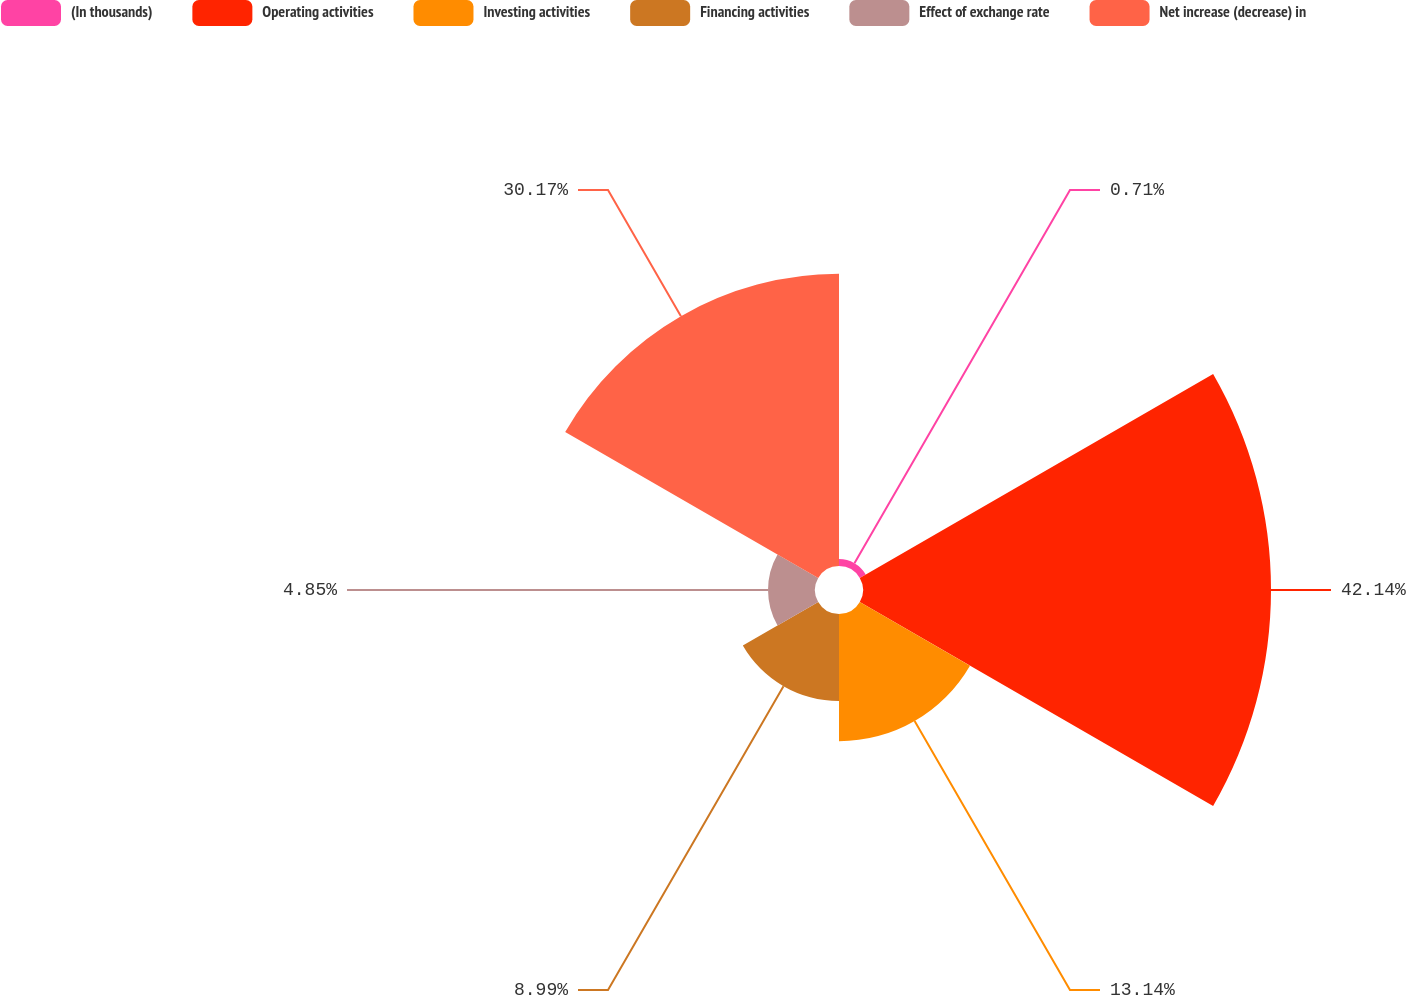<chart> <loc_0><loc_0><loc_500><loc_500><pie_chart><fcel>(In thousands)<fcel>Operating activities<fcel>Investing activities<fcel>Financing activities<fcel>Effect of exchange rate<fcel>Net increase (decrease) in<nl><fcel>0.71%<fcel>42.13%<fcel>13.14%<fcel>8.99%<fcel>4.85%<fcel>30.17%<nl></chart> 